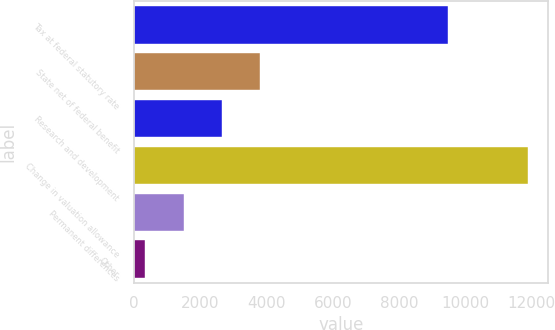Convert chart to OTSL. <chart><loc_0><loc_0><loc_500><loc_500><bar_chart><fcel>Tax at federal statutory rate<fcel>State net of federal benefit<fcel>Research and development<fcel>Change in valuation allowance<fcel>Permanent differences<fcel>Other<nl><fcel>9472<fcel>3813.6<fcel>2659.4<fcel>11893<fcel>1505.2<fcel>351<nl></chart> 